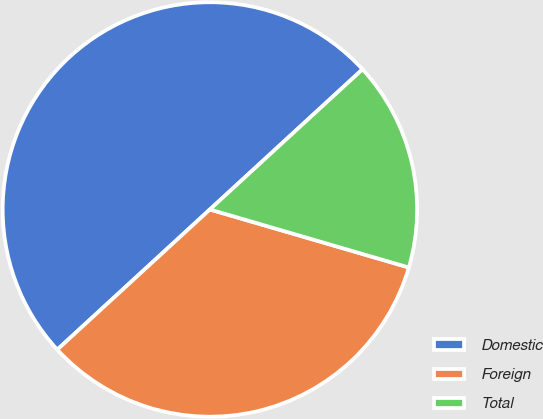<chart> <loc_0><loc_0><loc_500><loc_500><pie_chart><fcel>Domestic<fcel>Foreign<fcel>Total<nl><fcel>50.0%<fcel>33.66%<fcel>16.34%<nl></chart> 